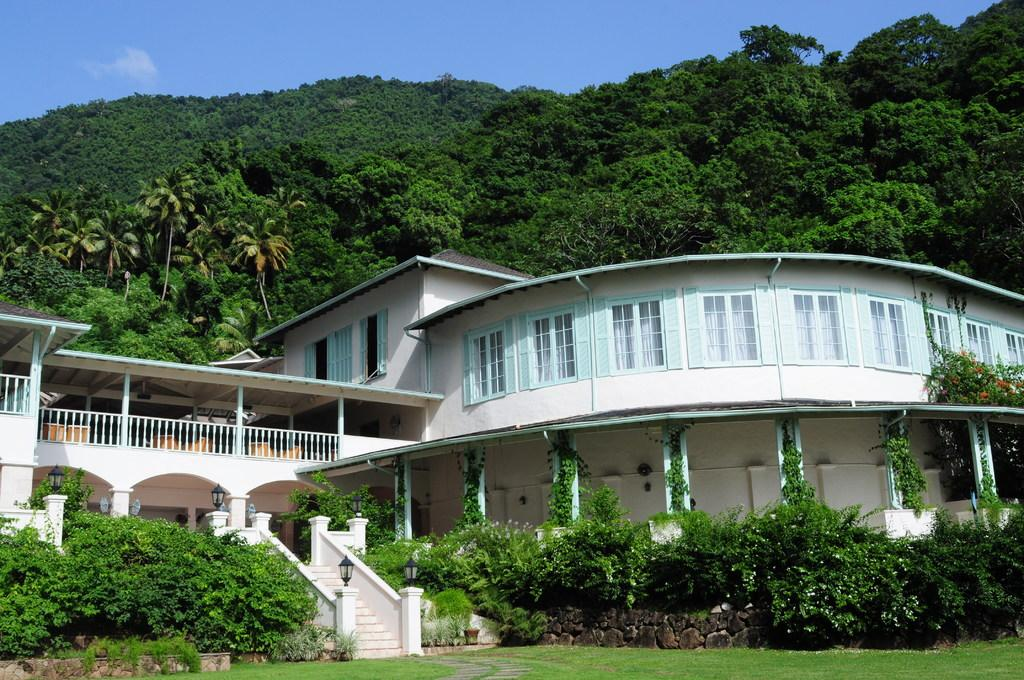What type of structure is visible in the image? There is a building in the image. What natural elements can be seen in the image? There are trees, plants, and grass on the ground in the image. Are there any architectural features in the image? Yes, there are stairs in the image. What is the condition of the sky in the image? The sky is blue in the image, with clouds visible. What type of lighting is present in the image? There are lights in the image. What health benefits can be gained from the disgusting substance seen in the image? There is no disgusting substance present in the image, and therefore no health benefits can be discussed. 